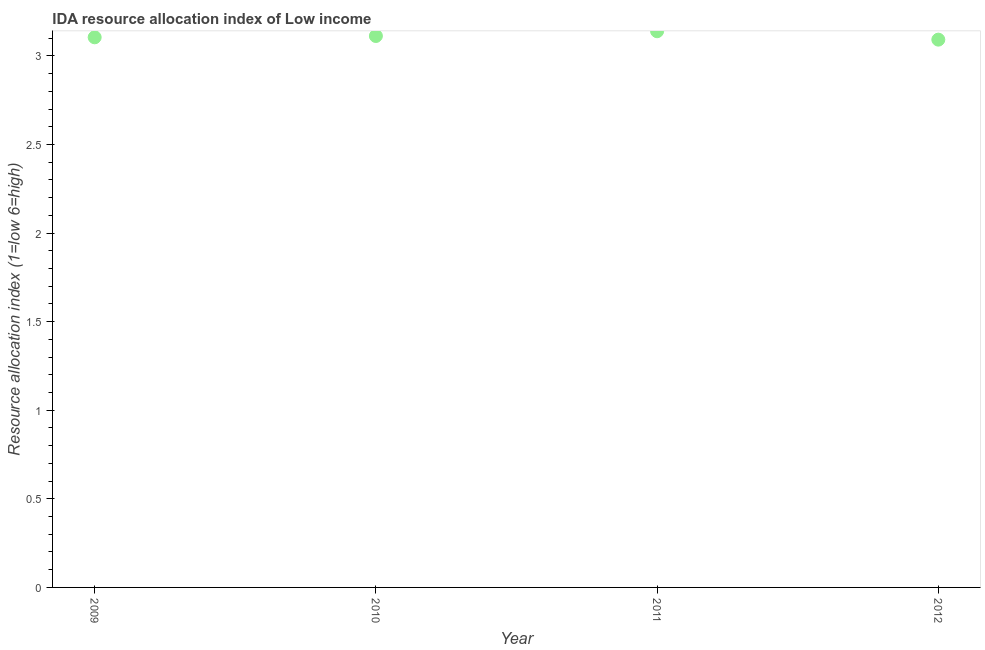What is the ida resource allocation index in 2012?
Ensure brevity in your answer.  3.09. Across all years, what is the maximum ida resource allocation index?
Your answer should be very brief. 3.14. Across all years, what is the minimum ida resource allocation index?
Give a very brief answer. 3.09. In which year was the ida resource allocation index maximum?
Offer a terse response. 2011. In which year was the ida resource allocation index minimum?
Ensure brevity in your answer.  2012. What is the sum of the ida resource allocation index?
Offer a terse response. 12.45. What is the difference between the ida resource allocation index in 2009 and 2011?
Your answer should be compact. -0.03. What is the average ida resource allocation index per year?
Your answer should be very brief. 3.11. What is the median ida resource allocation index?
Make the answer very short. 3.11. In how many years, is the ida resource allocation index greater than 0.4 ?
Ensure brevity in your answer.  4. Do a majority of the years between 2012 and 2010 (inclusive) have ida resource allocation index greater than 0.4 ?
Your answer should be very brief. No. What is the ratio of the ida resource allocation index in 2009 to that in 2011?
Offer a very short reply. 0.99. Is the difference between the ida resource allocation index in 2010 and 2012 greater than the difference between any two years?
Offer a terse response. No. What is the difference between the highest and the second highest ida resource allocation index?
Provide a succinct answer. 0.03. Is the sum of the ida resource allocation index in 2009 and 2012 greater than the maximum ida resource allocation index across all years?
Ensure brevity in your answer.  Yes. What is the difference between the highest and the lowest ida resource allocation index?
Provide a succinct answer. 0.05. Does the ida resource allocation index monotonically increase over the years?
Your answer should be very brief. No. How many years are there in the graph?
Keep it short and to the point. 4. What is the difference between two consecutive major ticks on the Y-axis?
Offer a terse response. 0.5. Does the graph contain any zero values?
Give a very brief answer. No. Does the graph contain grids?
Offer a very short reply. No. What is the title of the graph?
Your response must be concise. IDA resource allocation index of Low income. What is the label or title of the Y-axis?
Ensure brevity in your answer.  Resource allocation index (1=low 6=high). What is the Resource allocation index (1=low 6=high) in 2009?
Keep it short and to the point. 3.11. What is the Resource allocation index (1=low 6=high) in 2010?
Make the answer very short. 3.11. What is the Resource allocation index (1=low 6=high) in 2011?
Your answer should be very brief. 3.14. What is the Resource allocation index (1=low 6=high) in 2012?
Give a very brief answer. 3.09. What is the difference between the Resource allocation index (1=low 6=high) in 2009 and 2010?
Ensure brevity in your answer.  -0.01. What is the difference between the Resource allocation index (1=low 6=high) in 2009 and 2011?
Provide a short and direct response. -0.03. What is the difference between the Resource allocation index (1=low 6=high) in 2009 and 2012?
Keep it short and to the point. 0.01. What is the difference between the Resource allocation index (1=low 6=high) in 2010 and 2011?
Ensure brevity in your answer.  -0.03. What is the difference between the Resource allocation index (1=low 6=high) in 2010 and 2012?
Your answer should be very brief. 0.02. What is the difference between the Resource allocation index (1=low 6=high) in 2011 and 2012?
Provide a succinct answer. 0.05. What is the ratio of the Resource allocation index (1=low 6=high) in 2009 to that in 2010?
Keep it short and to the point. 1. What is the ratio of the Resource allocation index (1=low 6=high) in 2009 to that in 2012?
Provide a succinct answer. 1. What is the ratio of the Resource allocation index (1=low 6=high) in 2010 to that in 2012?
Give a very brief answer. 1.01. 